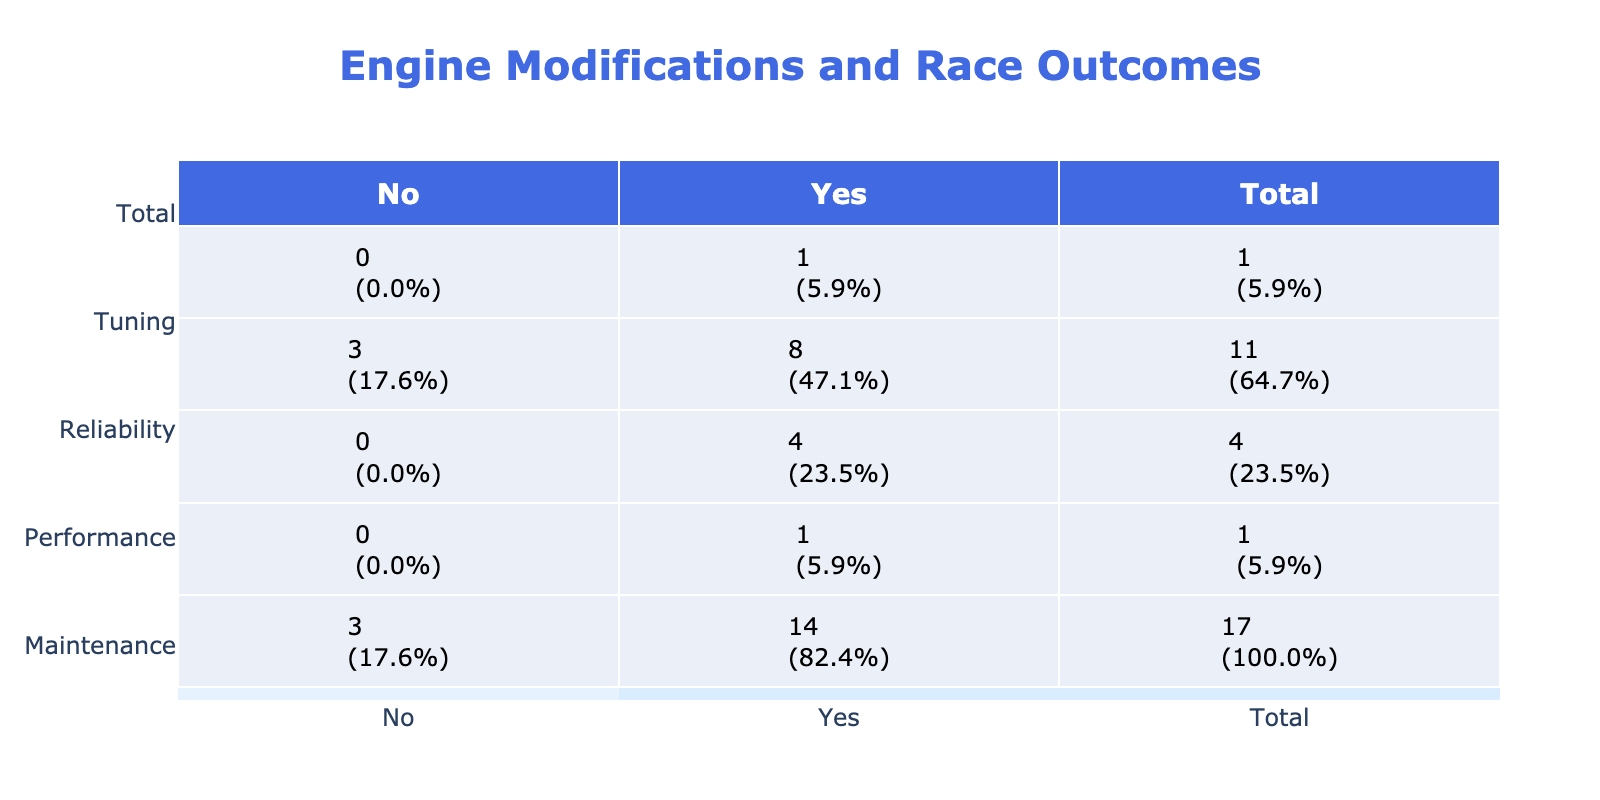What is the success rate for performance modifications? To find the success rate, we need to look at the total number of performance modifications and the number of successful ones. There are 11 performance modifications in total, out of which 8 were successful. The success rate is calculated as (8 successful / 11 total) * 100 = 72.7%.
Answer: 72.7% Which engine modification intended for reliability had a failure? The table categorizes modifications under types, and for reliability, the only modification listed is the "Stronger Cooling System," which is successful, as well as "Reinforced Engine Block" and "Oil Cooler Installation." Since there are no modifications for reliability that had a failure, looking for others that could lead us to a performance type which lists "Dual Fuel Rails" and "Piston Replacement," and of those, "Dual Fuel Rails" showed a failure.
Answer: Dual Fuel Rails What percentage of modifications are related to maintenance? Only one modification, "Premium Synthetic Oil," is classified as maintenance. Since there are 15 total modifications, the percentage is calculated as (1 maintenance / 15 total) * 100 = 6.7%.
Answer: 6.7% Are all reliability modifications successful? From the data, there are three modifications for reliability: "Stronger Cooling System," "Reinforced Engine Block," and "Oil Cooler Installation," all of which are marked as successful. This confirms that all reliability modifications have succeeded.
Answer: Yes What is the total number of unsuccessful modifications across all types? We need to count the unsuccessful modifications: "Lightweight Flywheel," "Dual Fuel Rails," and "Piston Replacement," totaling three unsuccessful modifications out of the total 15.
Answer: 3 How many modifications are successful for tuning compared to performance? The tuning category shows one successful modification ("Revised Timing Belt"). The performance category shows 8 successful modifications. Thus, comparing, the number of successful tuning modifications (1) is far less than for performance (8).
Answer: Tuning: 1, Performance: 8 Which type has the highest number of successful modifications? Upon reviewing the counts, performance has 8 successful modifications while reliability has 3 and maintenance has 1. Therefore, performance holds the highest number of successful modifications with 8.
Answer: Performance If we add together all reliability modifications regardless of success, what total do we get? The reliability category shows three modifications: "Stronger Cooling System," "Reinforced Engine Block," and "Oil Cooler Installation." When counted, they total to three modifications in reliability.
Answer: 3 